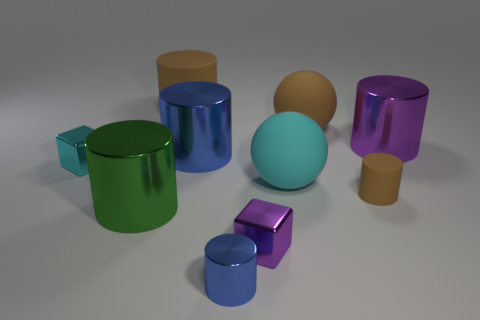What material is the big green cylinder?
Your answer should be compact. Metal. Are there more small purple blocks than tiny green metal cylinders?
Keep it short and to the point. Yes. Is the large green object the same shape as the tiny brown rubber object?
Your answer should be compact. Yes. There is a small block behind the tiny rubber cylinder; does it have the same color as the large ball behind the big purple metallic object?
Keep it short and to the point. No. Is the number of purple cylinders that are to the right of the big purple metal cylinder less than the number of spheres that are in front of the big cyan rubber object?
Your answer should be very brief. No. There is a blue shiny thing in front of the tiny cyan thing; what is its shape?
Provide a short and direct response. Cylinder. There is a object that is the same color as the small metallic cylinder; what material is it?
Make the answer very short. Metal. How many other things are there of the same material as the brown ball?
Your answer should be very brief. 3. There is a large green thing; does it have the same shape as the small thing that is in front of the tiny purple cube?
Keep it short and to the point. Yes. What shape is the big green object that is made of the same material as the cyan cube?
Offer a very short reply. Cylinder. 